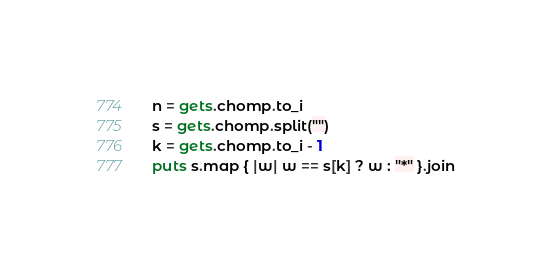<code> <loc_0><loc_0><loc_500><loc_500><_Ruby_>n = gets.chomp.to_i
s = gets.chomp.split("")
k = gets.chomp.to_i - 1
puts s.map { |w| w == s[k] ? w : "*" }.join
</code> 